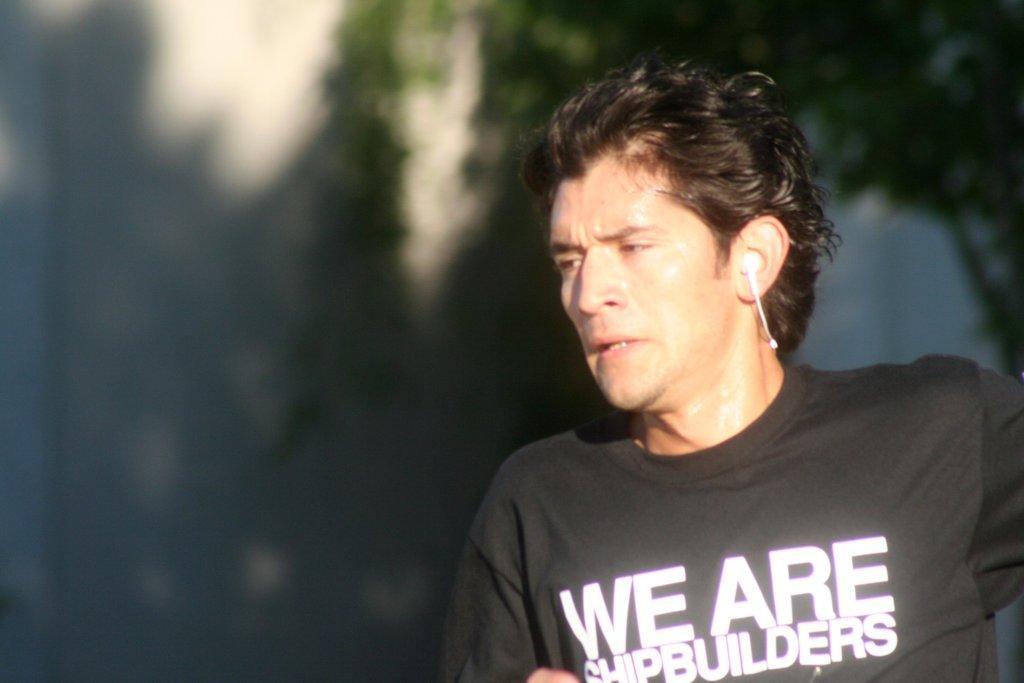Describe this image in one or two sentences. On the right we can see a man and there is a headset in his ear. In the background the image is blur but we can see a tree on the right side. 